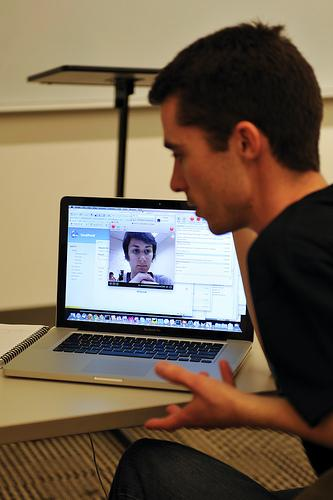What unique features can be observed on the laptop screen, and what are the implications? The laptop screen displays a FaceTime video, camera light, and picture of a woman, suggesting that the man is engaged in a video call with someone over the internet. Identify the person's appearance and their current activity. The man has brown hair, wears a black shirt and blue jeans, and he is sitting in front of a silver laptop, engaged in a video call with a woman on Skype. Considering a multi-choice VQA task, what is the color of the man's hair and pants? Brown hair, blue jeans. In a product advertisement, highlight the laptop and its main characteristics. Introducing our latest sleek and stylish silver Macbook, featuring a responsive grey keyboard with taskbar icons, user-friendly touchpad, and crystal clear FaceTime video capabilities for all your video calling needs! For a visual entailment task, indicate whether the following statement is true or false: "The room has white walls and a white ceiling." True What is a unique feature of this man's sitting posture? The man's hand is open and in motion, suggesting some kind of movement or gesture during the video call. Mention three objects found on the table and describe their locations. A silver Macbook with the screen turned on, a notebook with notes to the left of the laptop, and a lamp with a black post in the background on the right side. What type of clothing is the man wearing and what color is his top? The man is wearing jeans as pants and a black shirt as a top. In a referential expression grounding task, describe the location and appearance of the man's eyebrows, nose, and mouth. The man's eyebrow is located above his eye, which is above his nose, and the mouth is below the nose. The eyebrow is relatively thicker, the nose is narrow, and the mouth is positioned centrally on his face. Identify two additional objects or details in the image. A black lamp post in the background and a black power cord under the table. 